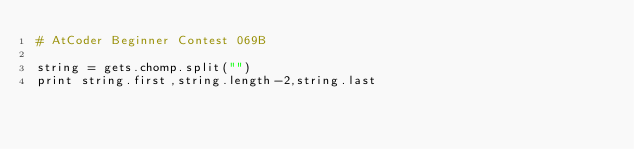<code> <loc_0><loc_0><loc_500><loc_500><_Ruby_># AtCoder Beginner Contest 069B

string = gets.chomp.split("")
print string.first,string.length-2,string.last</code> 